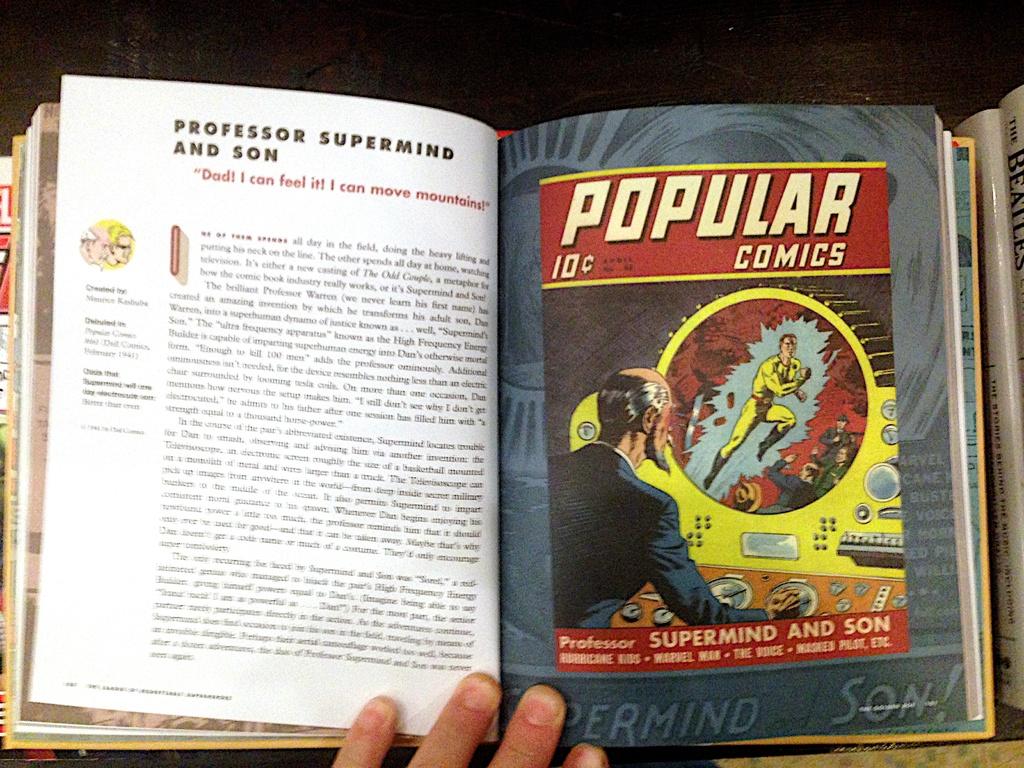How much did this comic cost?
Give a very brief answer. 10 cents. 